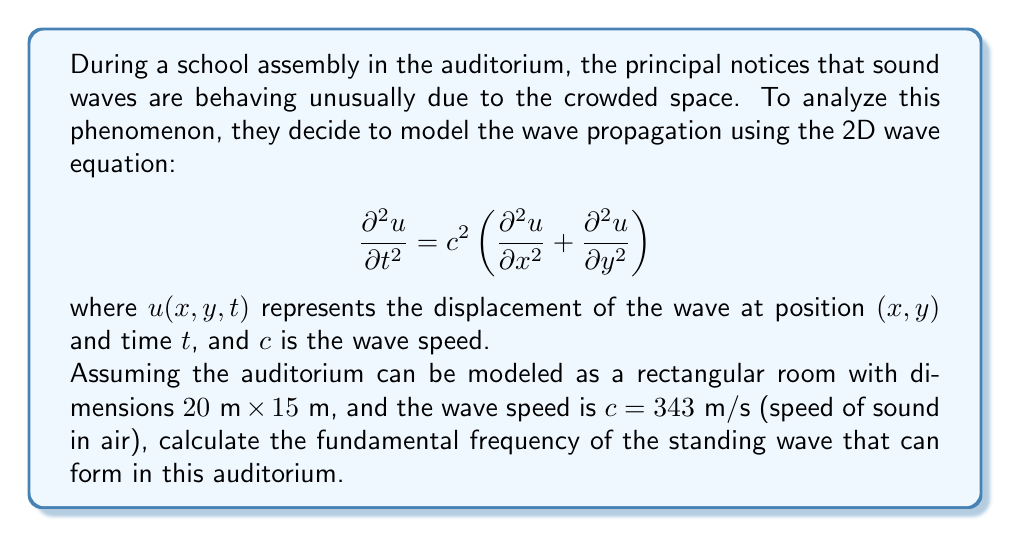Provide a solution to this math problem. To solve this problem, we need to follow these steps:

1) For a rectangular room, the general solution for the standing wave is given by:

   $$u(x,y,t) = A \sin(\omega t) \sin(k_x x) \sin(k_y y)$$

   where $A$ is the amplitude, $\omega$ is the angular frequency, and $k_x$ and $k_y$ are the wave numbers in the x and y directions respectively.

2) The boundary conditions for a rectangular room with dimensions $L_x$ and $L_y$ are:

   $$k_x = \frac{n_x \pi}{L_x}, \quad k_y = \frac{n_y \pi}{L_y}$$

   where $n_x$ and $n_y$ are positive integers.

3) The dispersion relation for the 2D wave equation is:

   $$\omega^2 = c^2(k_x^2 + k_y^2)$$

4) Substituting the boundary conditions:

   $$\omega^2 = c^2 \left(\frac{n_x^2 \pi^2}{L_x^2} + \frac{n_y^2 \pi^2}{L_y^2}\right)$$

5) The fundamental frequency corresponds to the lowest possible frequency, which occurs when $n_x = n_y = 1$. Therefore:

   $$\omega^2 = c^2 \pi^2 \left(\frac{1}{L_x^2} + \frac{1}{L_y^2}\right)$$

6) The frequency $f$ is related to $\omega$ by $\omega = 2\pi f$. So:

   $$f = \frac{c}{2} \sqrt{\frac{1}{L_x^2} + \frac{1}{L_y^2}}$$

7) Now, let's substitute the given values:
   $c = 343\text{ m/s}$, $L_x = 20\text{ m}$, $L_y = 15\text{ m}$

   $$f = \frac{343}{2} \sqrt{\frac{1}{20^2} + \frac{1}{15^2}}$$

8) Calculating:

   $$f = 171.5 \sqrt{\frac{1}{400} + \frac{1}{225}} = 171.5 \sqrt{0.0025 + 0.0044} = 171.5 \sqrt{0.0069} \approx 14.24\text{ Hz}$$

Therefore, the fundamental frequency of the standing wave in this auditorium is approximately 14.24 Hz.
Answer: $14.24\text{ Hz}$ 